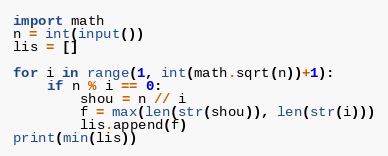<code> <loc_0><loc_0><loc_500><loc_500><_Python_>import math
n = int(input())
lis = []

for i in range(1, int(math.sqrt(n))+1):
    if n % i == 0:
        shou = n // i
        f = max(len(str(shou)), len(str(i)))
        lis.append(f)
print(min(lis))</code> 